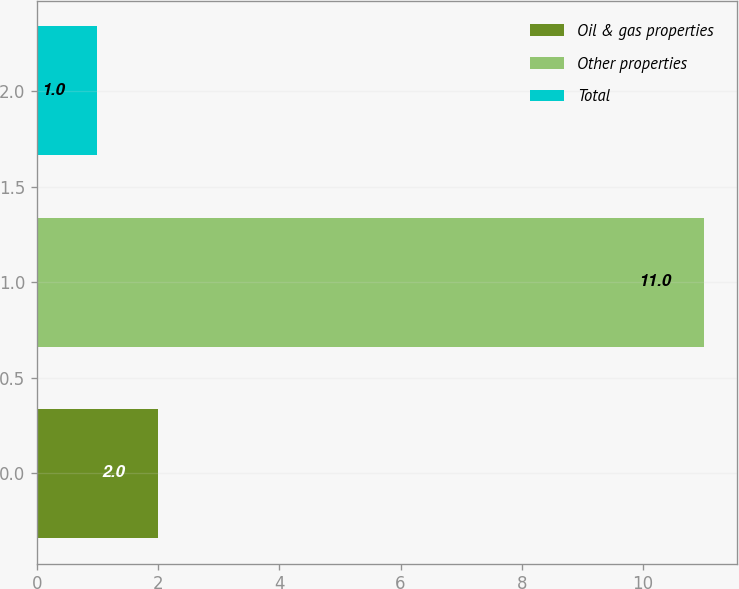Convert chart. <chart><loc_0><loc_0><loc_500><loc_500><bar_chart><fcel>Oil & gas properties<fcel>Other properties<fcel>Total<nl><fcel>2<fcel>11<fcel>1<nl></chart> 